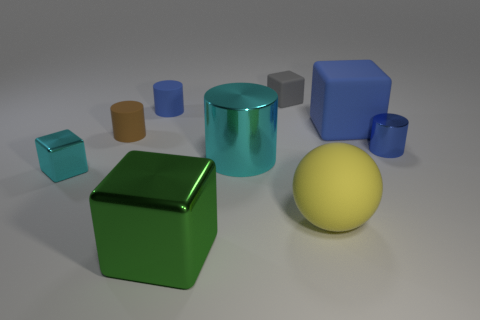Add 1 big rubber objects. How many objects exist? 10 Subtract all cubes. How many objects are left? 5 Add 1 tiny blue things. How many tiny blue things exist? 3 Subtract 1 blue blocks. How many objects are left? 8 Subtract all big blocks. Subtract all blue objects. How many objects are left? 4 Add 3 brown rubber cylinders. How many brown rubber cylinders are left? 4 